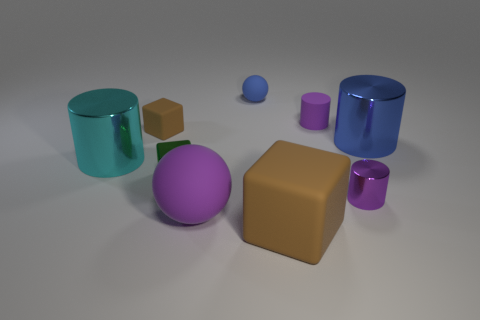Subtract all rubber blocks. How many blocks are left? 1 Add 1 tiny red things. How many objects exist? 10 Subtract all brown blocks. How many blocks are left? 1 Subtract all blocks. How many objects are left? 6 Subtract 1 cylinders. How many cylinders are left? 3 Subtract all brown spheres. Subtract all cyan cylinders. How many spheres are left? 2 Subtract all purple blocks. How many purple cylinders are left? 2 Subtract all matte balls. Subtract all large gray rubber balls. How many objects are left? 7 Add 6 large cyan shiny objects. How many large cyan shiny objects are left? 7 Add 1 red metal things. How many red metal things exist? 1 